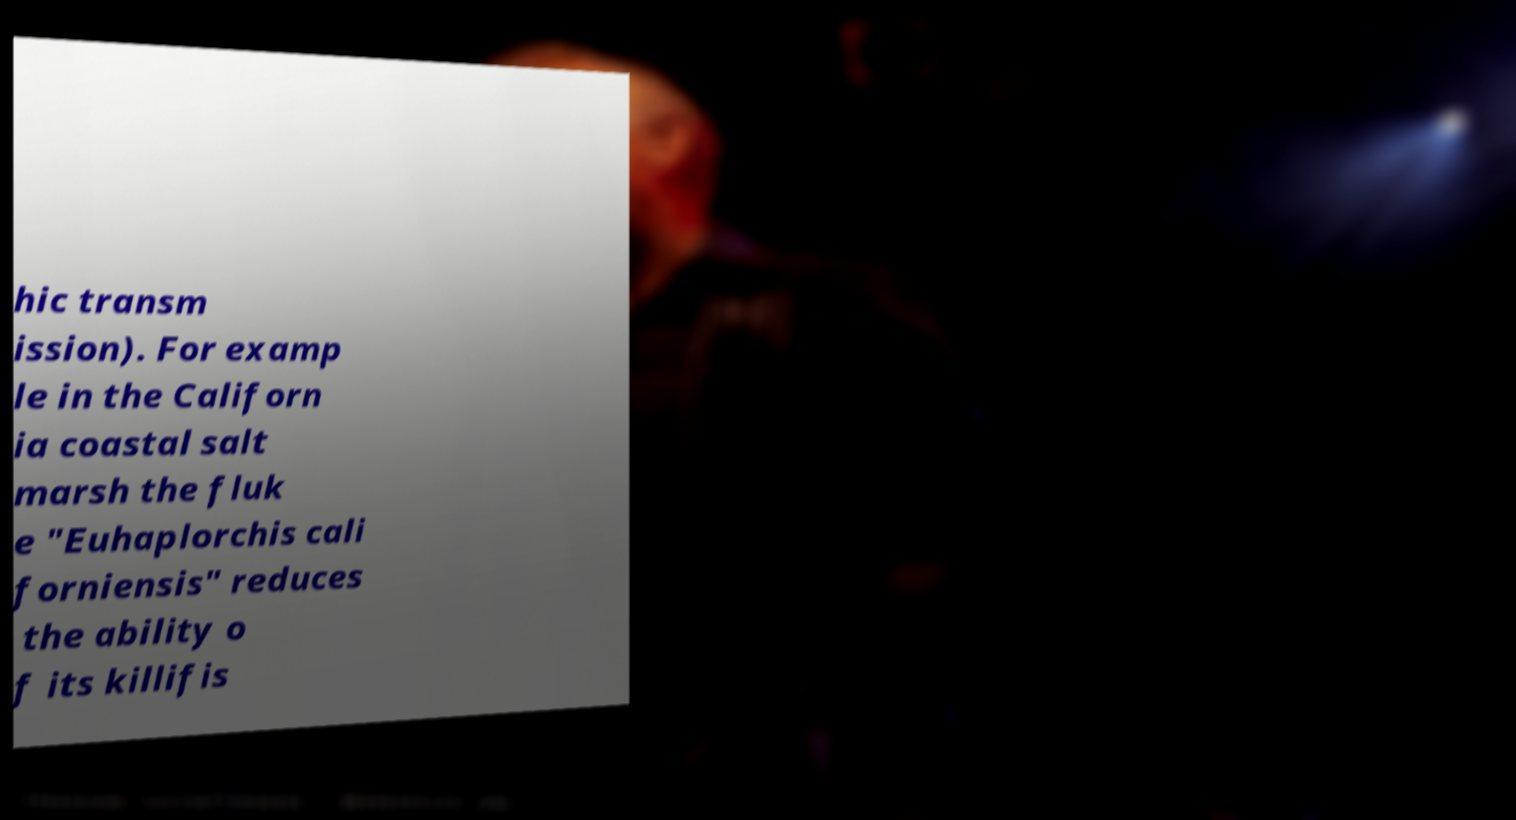What messages or text are displayed in this image? I need them in a readable, typed format. hic transm ission). For examp le in the Californ ia coastal salt marsh the fluk e "Euhaplorchis cali forniensis" reduces the ability o f its killifis 